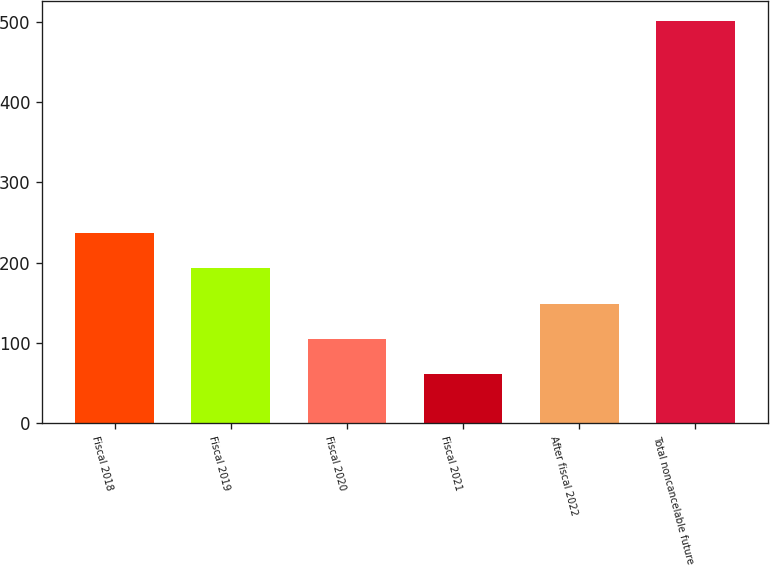Convert chart. <chart><loc_0><loc_0><loc_500><loc_500><bar_chart><fcel>Fiscal 2018<fcel>Fiscal 2019<fcel>Fiscal 2020<fcel>Fiscal 2021<fcel>After fiscal 2022<fcel>Total noncancelable future<nl><fcel>236.7<fcel>192.7<fcel>104.7<fcel>60.7<fcel>148.7<fcel>500.7<nl></chart> 